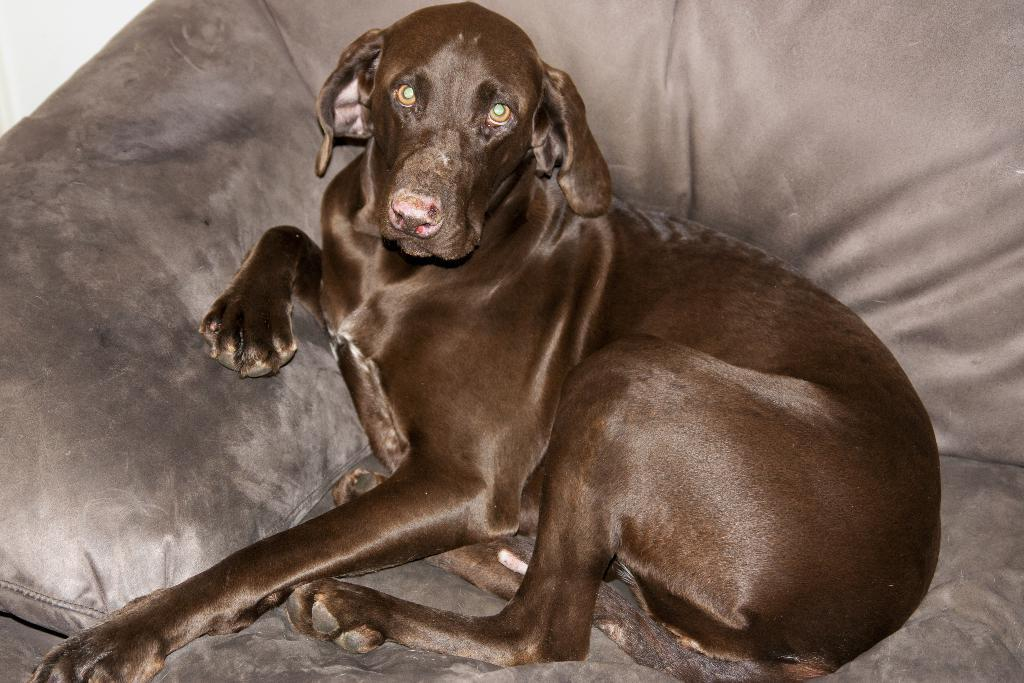What type of animal is in the image? There is a black dog in the image. Where is the dog located? The dog is sitting on a couch. What can be seen in the top left corner of the image? There is a wall visible in the top left corner of the image. What type of yarn is the dog using to knit a scarf in the image? There is no yarn or knitting activity present in the image; the dog is simply sitting on a couch. 